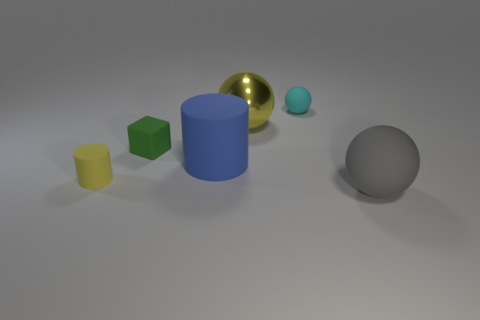What shape is the matte object that is the same color as the metal ball?
Make the answer very short. Cylinder. Are there more big yellow metal balls than small yellow balls?
Your response must be concise. Yes. What is the color of the large thing to the left of the yellow thing that is right of the small matte thing in front of the big blue matte cylinder?
Provide a short and direct response. Blue. There is a small thing that is behind the large yellow metal thing; is it the same shape as the big blue thing?
Your answer should be compact. No. The cylinder that is the same size as the cyan sphere is what color?
Your response must be concise. Yellow. How many blue cylinders are there?
Your answer should be very brief. 1. Is the material of the tiny yellow cylinder behind the gray ball the same as the blue cylinder?
Give a very brief answer. Yes. There is a thing that is both behind the green cube and left of the small cyan thing; what material is it?
Offer a terse response. Metal. What is the size of the metallic object that is the same color as the small cylinder?
Keep it short and to the point. Large. There is a large ball behind the yellow object that is to the left of the large matte cylinder; what is it made of?
Your response must be concise. Metal. 